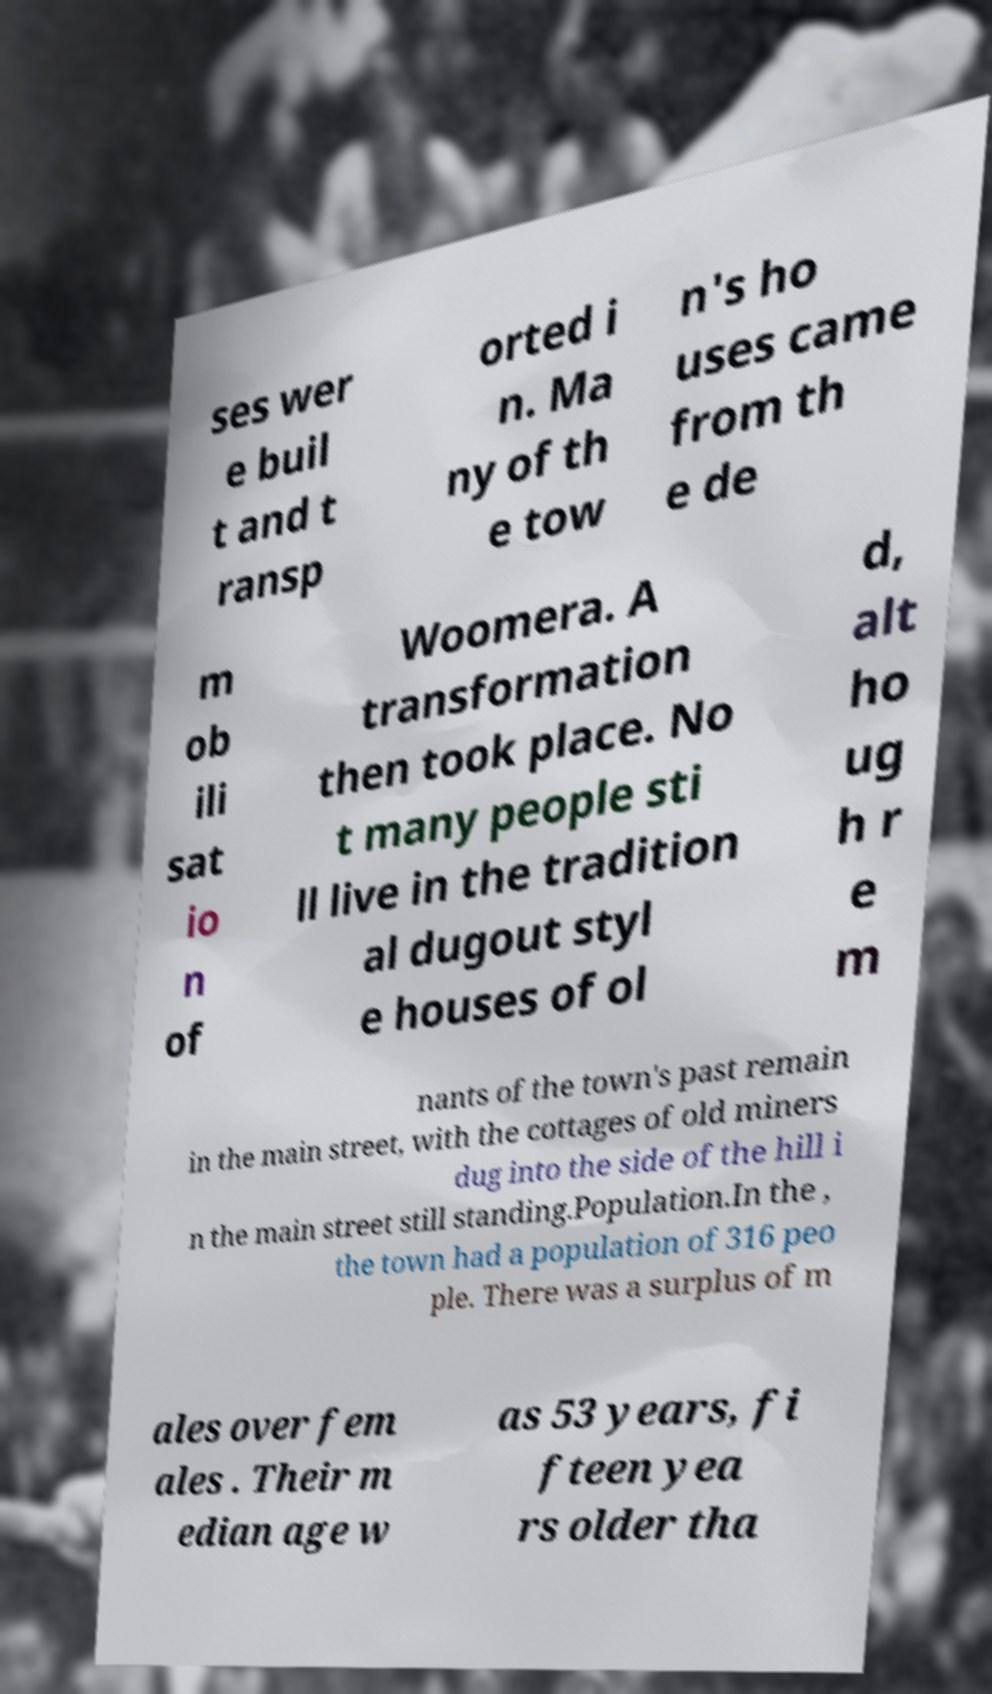Could you extract and type out the text from this image? ses wer e buil t and t ransp orted i n. Ma ny of th e tow n's ho uses came from th e de m ob ili sat io n of Woomera. A transformation then took place. No t many people sti ll live in the tradition al dugout styl e houses of ol d, alt ho ug h r e m nants of the town's past remain in the main street, with the cottages of old miners dug into the side of the hill i n the main street still standing.Population.In the , the town had a population of 316 peo ple. There was a surplus of m ales over fem ales . Their m edian age w as 53 years, fi fteen yea rs older tha 